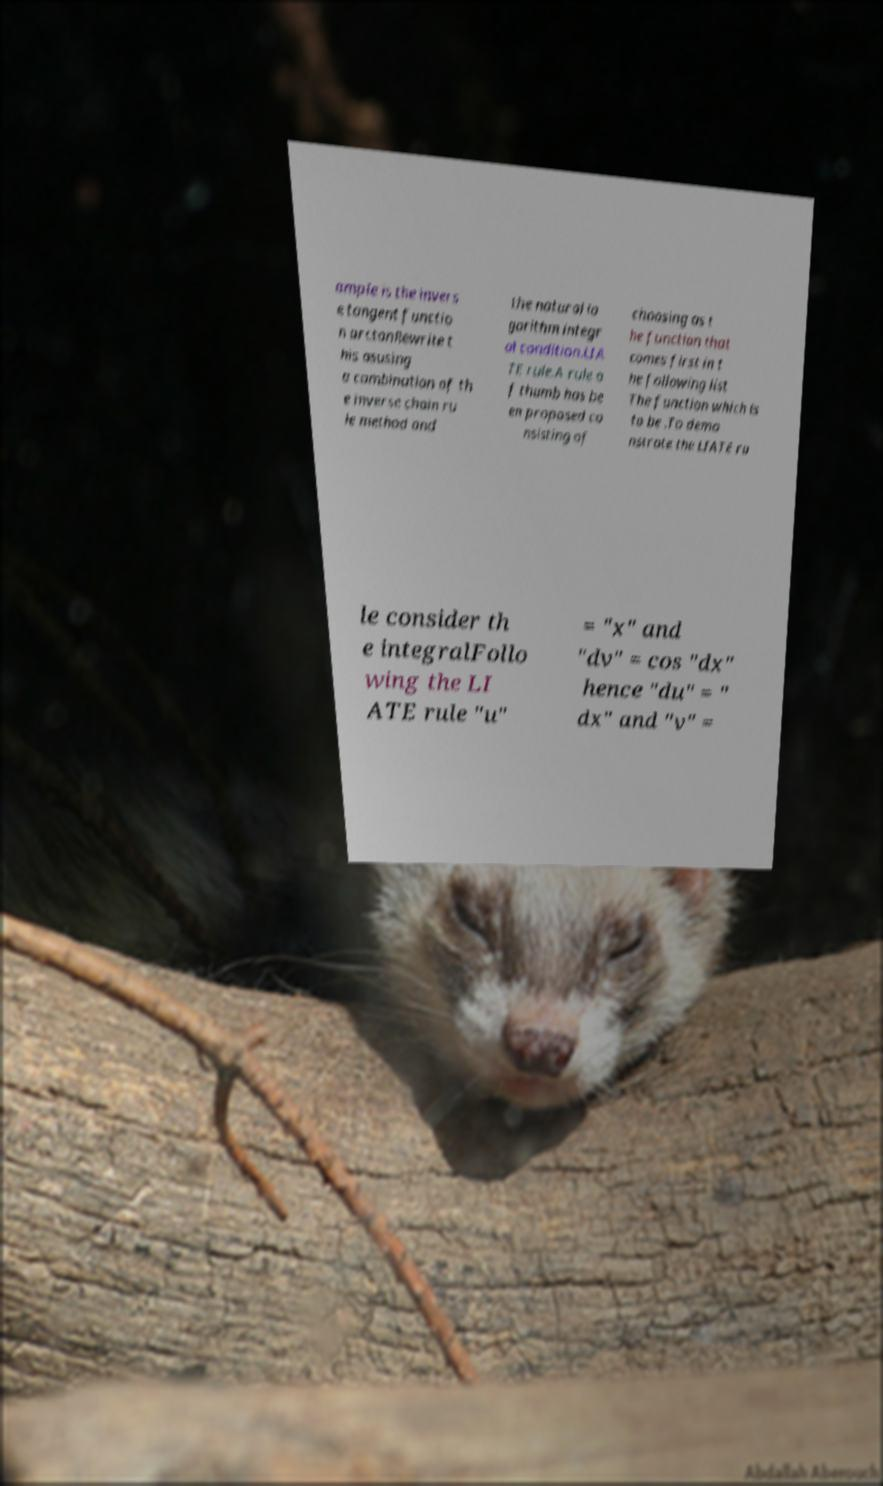What messages or text are displayed in this image? I need them in a readable, typed format. ample is the invers e tangent functio n arctanRewrite t his asusing a combination of th e inverse chain ru le method and the natural lo garithm integr al condition.LIA TE rule.A rule o f thumb has be en proposed co nsisting of choosing as t he function that comes first in t he following list The function which is to be .To demo nstrate the LIATE ru le consider th e integralFollo wing the LI ATE rule "u" = "x" and "dv" = cos "dx" hence "du" = " dx" and "v" = 